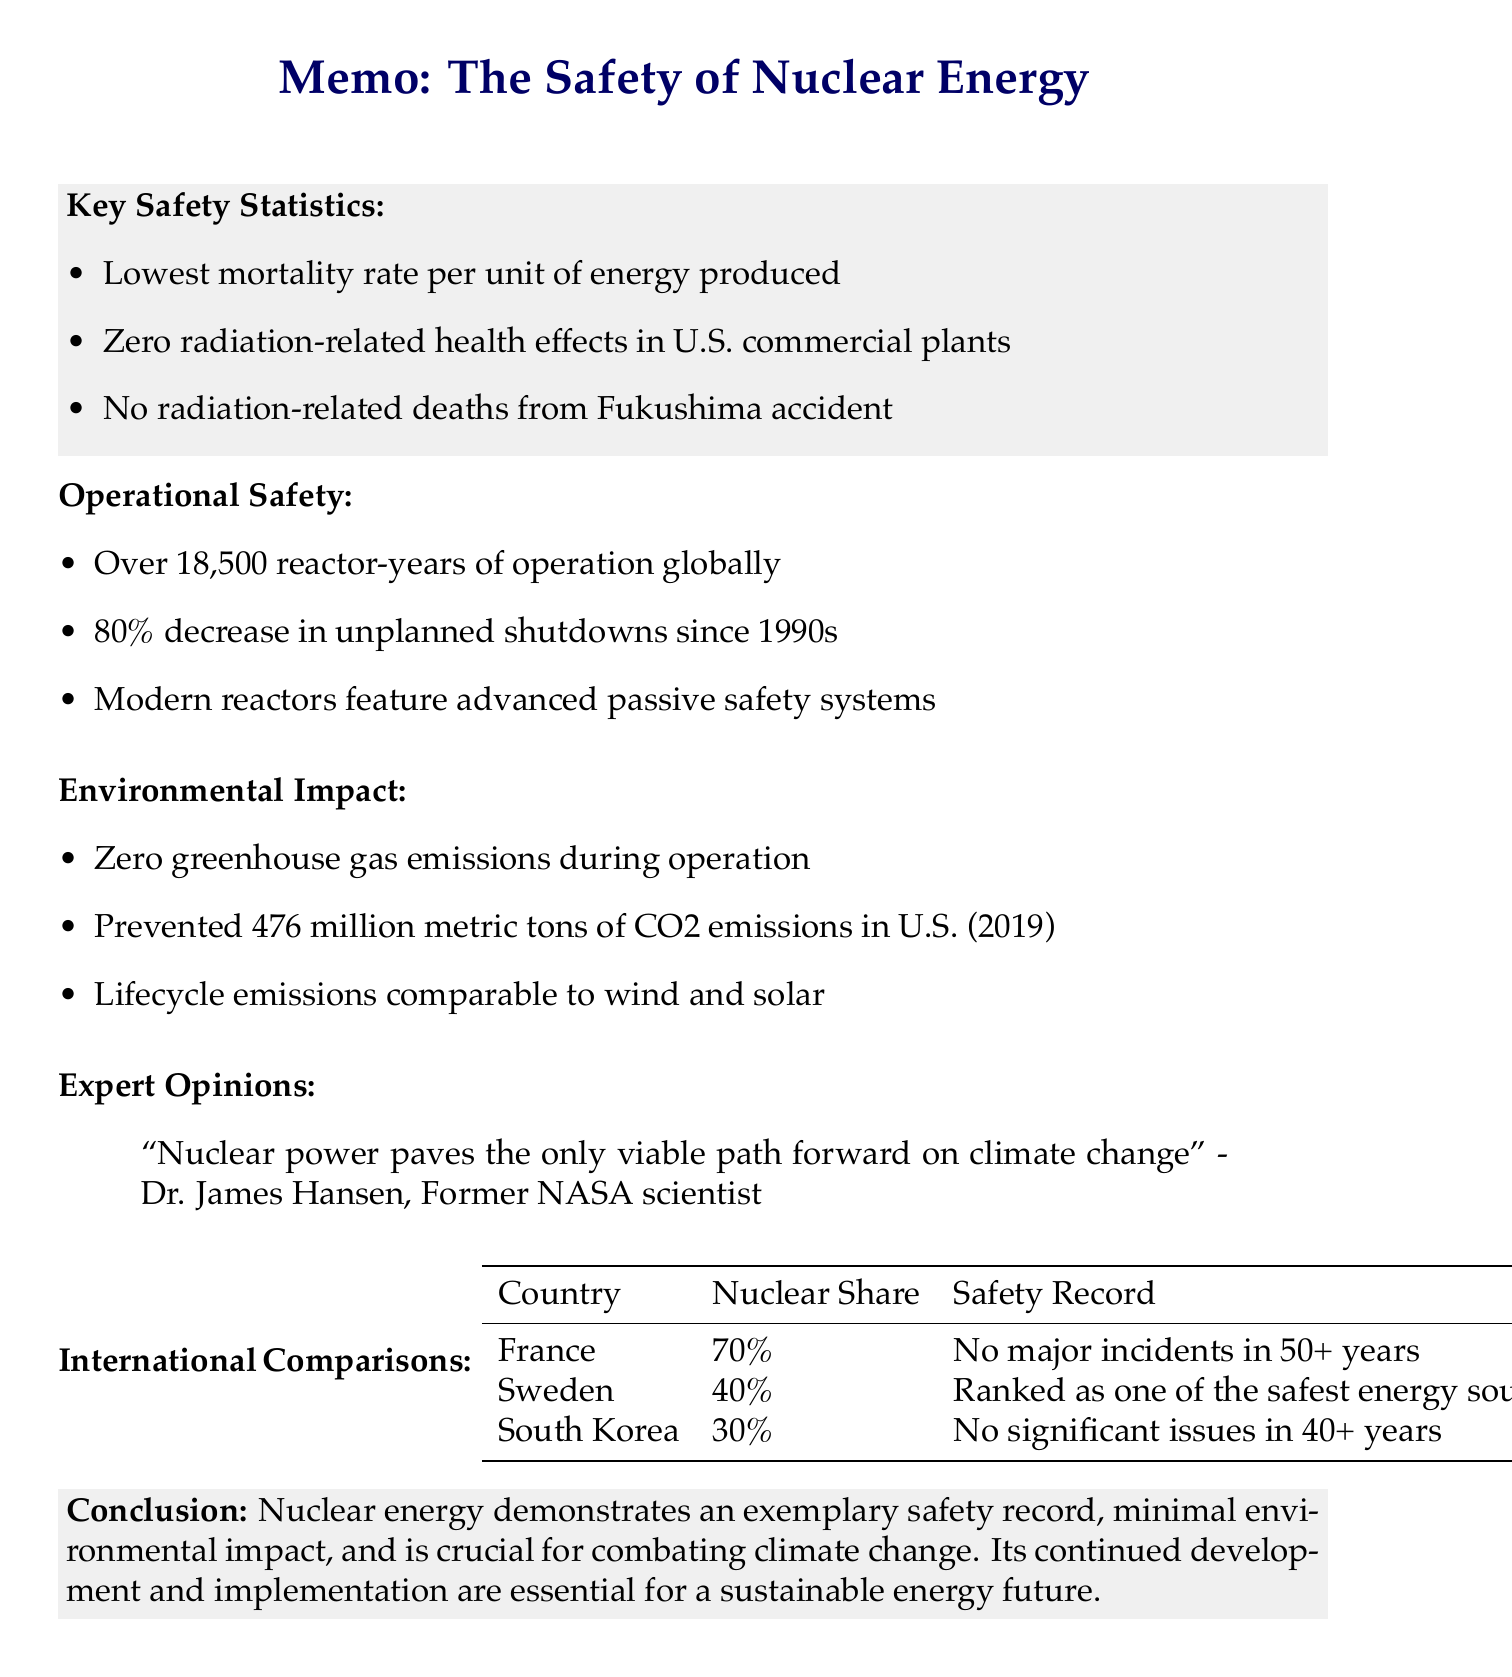What is the mortality rate of nuclear energy per unit of energy produced? Nuclear energy has the lowest mortality rate per unit of energy produced compared to other major energy sources, according to a 2020 study by Our World in Data.
Answer: Lowest How many major accidents has the global nuclear industry experienced? The global nuclear industry has accumulated over 18,500 reactor-years of operation as of 2021, with only three major accidents (Three Mile Island, Chernobyl, and Fukushima).
Answer: Three What percentage of electricity production does France generate from nuclear energy? France generates 70% of its electricity from nuclear energy and has no major incidents in over 50 years of operation.
Answer: 70% What significant greenhouse gas emissions did U.S. nuclear power plants prevent in 2019? The Nuclear Energy Institute states that U.S. nuclear power plants prevented 476 million metric tons of carbon dioxide emissions in 2019.
Answer: 476 million metric tons Which advanced reactor design is mentioned as having the potential to reduce nuclear waste? Advanced reactor designs, such as molten salt reactors, have the potential to significantly reduce nuclear waste volumes and radioactive lifetimes.
Answer: Molten salt reactors What does the United States Nuclear Regulatory Commission enforce regarding radiation doses? The United States Nuclear Regulatory Commission enforces a radiation dose limit for the public from nuclear power plants that is 100 times lower than average natural background radiation.
Answer: 100 times lower Which expert believes that nuclear power is vital for addressing climate change? Dr. James Hansen, a former NASA scientist and climate expert, states that "Nuclear power paves the only viable path forward on climate change."
Answer: Dr. James Hansen What is the primary environmental impact of nuclear power plants during operation? Nuclear power plants emit no greenhouse gases during operation, making them a key tool in combating climate change.
Answer: No greenhouse gases 